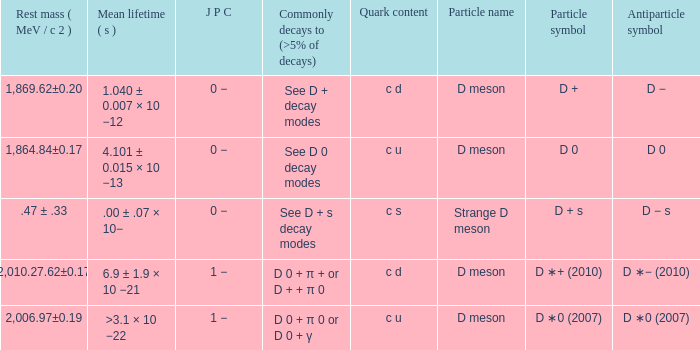What is the j p c that commonly decays (>5% of decays) d 0 + π 0 or d 0 + γ? 1 −. 